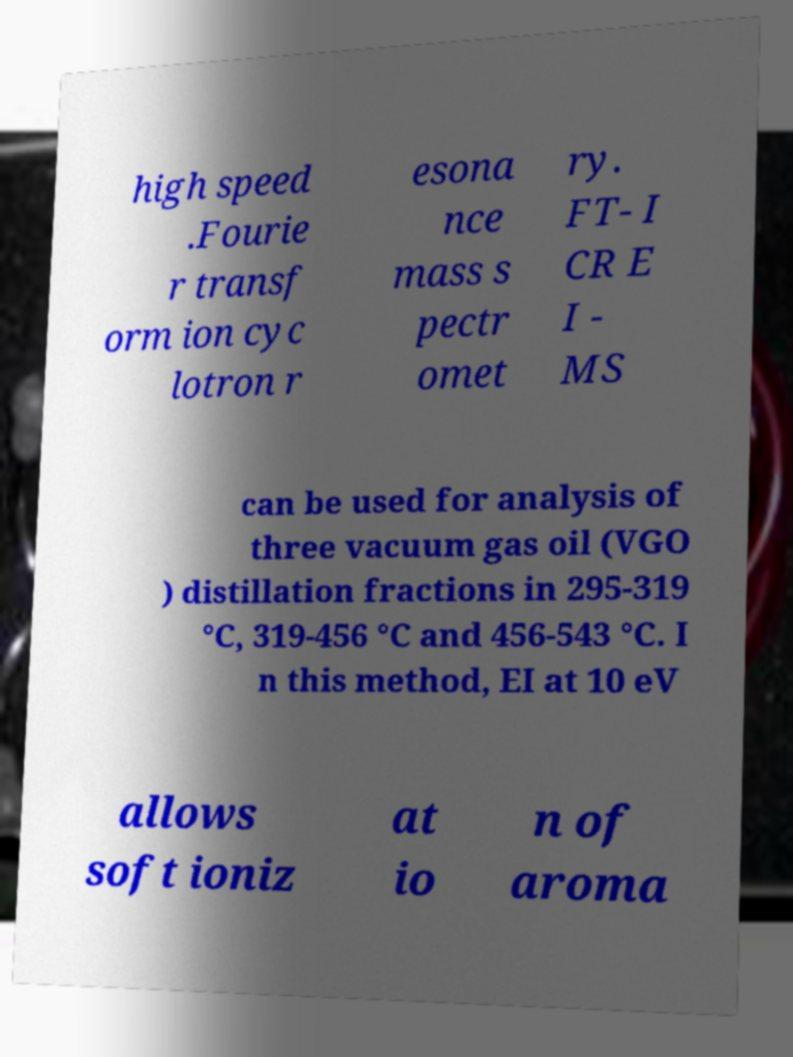Please identify and transcribe the text found in this image. high speed .Fourie r transf orm ion cyc lotron r esona nce mass s pectr omet ry. FT- I CR E I - MS can be used for analysis of three vacuum gas oil (VGO ) distillation fractions in 295-319 °C, 319-456 °C and 456-543 °C. I n this method, EI at 10 eV allows soft ioniz at io n of aroma 